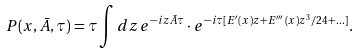<formula> <loc_0><loc_0><loc_500><loc_500>P ( x , \bar { A } , \tau ) = \tau \int { d z \, e ^ { - i z \bar { A } \tau } \cdot e ^ { - { i } \tau [ E ^ { \prime } ( x ) z + E ^ { \prime \prime \prime } ( x ) z ^ { 3 } / 2 4 + \dots ] } } .</formula> 